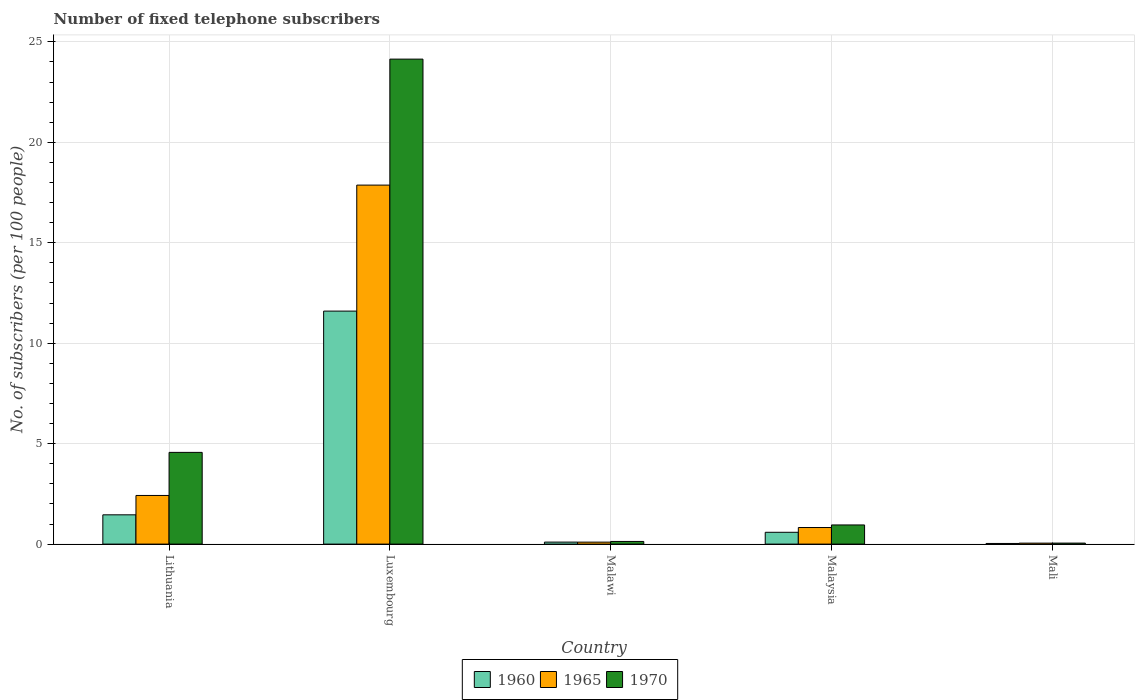How many groups of bars are there?
Ensure brevity in your answer.  5. Are the number of bars per tick equal to the number of legend labels?
Provide a succinct answer. Yes. Are the number of bars on each tick of the X-axis equal?
Offer a very short reply. Yes. How many bars are there on the 4th tick from the left?
Your response must be concise. 3. What is the label of the 1st group of bars from the left?
Your answer should be very brief. Lithuania. In how many cases, is the number of bars for a given country not equal to the number of legend labels?
Your answer should be compact. 0. What is the number of fixed telephone subscribers in 1960 in Lithuania?
Give a very brief answer. 1.46. Across all countries, what is the maximum number of fixed telephone subscribers in 1960?
Your answer should be very brief. 11.6. Across all countries, what is the minimum number of fixed telephone subscribers in 1970?
Offer a terse response. 0.05. In which country was the number of fixed telephone subscribers in 1970 maximum?
Your response must be concise. Luxembourg. In which country was the number of fixed telephone subscribers in 1965 minimum?
Your response must be concise. Mali. What is the total number of fixed telephone subscribers in 1965 in the graph?
Ensure brevity in your answer.  21.26. What is the difference between the number of fixed telephone subscribers in 1970 in Malaysia and that in Mali?
Make the answer very short. 0.9. What is the difference between the number of fixed telephone subscribers in 1960 in Lithuania and the number of fixed telephone subscribers in 1965 in Luxembourg?
Your answer should be compact. -16.41. What is the average number of fixed telephone subscribers in 1965 per country?
Provide a succinct answer. 4.25. What is the difference between the number of fixed telephone subscribers of/in 1970 and number of fixed telephone subscribers of/in 1960 in Lithuania?
Offer a very short reply. 3.11. In how many countries, is the number of fixed telephone subscribers in 1970 greater than 9?
Your answer should be very brief. 1. What is the ratio of the number of fixed telephone subscribers in 1960 in Malaysia to that in Mali?
Provide a succinct answer. 18.21. Is the number of fixed telephone subscribers in 1960 in Lithuania less than that in Malawi?
Offer a very short reply. No. What is the difference between the highest and the second highest number of fixed telephone subscribers in 1970?
Give a very brief answer. 23.19. What is the difference between the highest and the lowest number of fixed telephone subscribers in 1965?
Offer a very short reply. 17.82. What does the 1st bar from the left in Luxembourg represents?
Provide a succinct answer. 1960. What does the 2nd bar from the right in Lithuania represents?
Make the answer very short. 1965. How many bars are there?
Your response must be concise. 15. How many countries are there in the graph?
Your response must be concise. 5. Are the values on the major ticks of Y-axis written in scientific E-notation?
Offer a terse response. No. How are the legend labels stacked?
Give a very brief answer. Horizontal. What is the title of the graph?
Keep it short and to the point. Number of fixed telephone subscribers. What is the label or title of the X-axis?
Ensure brevity in your answer.  Country. What is the label or title of the Y-axis?
Offer a terse response. No. of subscribers (per 100 people). What is the No. of subscribers (per 100 people) of 1960 in Lithuania?
Make the answer very short. 1.46. What is the No. of subscribers (per 100 people) of 1965 in Lithuania?
Give a very brief answer. 2.42. What is the No. of subscribers (per 100 people) of 1970 in Lithuania?
Ensure brevity in your answer.  4.57. What is the No. of subscribers (per 100 people) in 1960 in Luxembourg?
Your answer should be compact. 11.6. What is the No. of subscribers (per 100 people) of 1965 in Luxembourg?
Keep it short and to the point. 17.87. What is the No. of subscribers (per 100 people) of 1970 in Luxembourg?
Provide a short and direct response. 24.14. What is the No. of subscribers (per 100 people) of 1960 in Malawi?
Ensure brevity in your answer.  0.1. What is the No. of subscribers (per 100 people) of 1965 in Malawi?
Provide a short and direct response. 0.1. What is the No. of subscribers (per 100 people) in 1970 in Malawi?
Give a very brief answer. 0.13. What is the No. of subscribers (per 100 people) of 1960 in Malaysia?
Your answer should be very brief. 0.59. What is the No. of subscribers (per 100 people) in 1965 in Malaysia?
Keep it short and to the point. 0.83. What is the No. of subscribers (per 100 people) of 1970 in Malaysia?
Provide a succinct answer. 0.95. What is the No. of subscribers (per 100 people) in 1960 in Mali?
Provide a succinct answer. 0.03. What is the No. of subscribers (per 100 people) of 1965 in Mali?
Give a very brief answer. 0.05. What is the No. of subscribers (per 100 people) of 1970 in Mali?
Make the answer very short. 0.05. Across all countries, what is the maximum No. of subscribers (per 100 people) in 1960?
Your answer should be compact. 11.6. Across all countries, what is the maximum No. of subscribers (per 100 people) in 1965?
Give a very brief answer. 17.87. Across all countries, what is the maximum No. of subscribers (per 100 people) of 1970?
Provide a succinct answer. 24.14. Across all countries, what is the minimum No. of subscribers (per 100 people) of 1960?
Provide a short and direct response. 0.03. Across all countries, what is the minimum No. of subscribers (per 100 people) of 1965?
Provide a succinct answer. 0.05. Across all countries, what is the minimum No. of subscribers (per 100 people) of 1970?
Your answer should be very brief. 0.05. What is the total No. of subscribers (per 100 people) of 1960 in the graph?
Give a very brief answer. 13.78. What is the total No. of subscribers (per 100 people) of 1965 in the graph?
Provide a short and direct response. 21.26. What is the total No. of subscribers (per 100 people) in 1970 in the graph?
Offer a very short reply. 29.84. What is the difference between the No. of subscribers (per 100 people) in 1960 in Lithuania and that in Luxembourg?
Give a very brief answer. -10.14. What is the difference between the No. of subscribers (per 100 people) in 1965 in Lithuania and that in Luxembourg?
Make the answer very short. -15.45. What is the difference between the No. of subscribers (per 100 people) of 1970 in Lithuania and that in Luxembourg?
Provide a short and direct response. -19.58. What is the difference between the No. of subscribers (per 100 people) in 1960 in Lithuania and that in Malawi?
Your answer should be very brief. 1.36. What is the difference between the No. of subscribers (per 100 people) in 1965 in Lithuania and that in Malawi?
Ensure brevity in your answer.  2.32. What is the difference between the No. of subscribers (per 100 people) in 1970 in Lithuania and that in Malawi?
Offer a very short reply. 4.43. What is the difference between the No. of subscribers (per 100 people) in 1960 in Lithuania and that in Malaysia?
Make the answer very short. 0.87. What is the difference between the No. of subscribers (per 100 people) in 1965 in Lithuania and that in Malaysia?
Provide a succinct answer. 1.6. What is the difference between the No. of subscribers (per 100 people) of 1970 in Lithuania and that in Malaysia?
Give a very brief answer. 3.61. What is the difference between the No. of subscribers (per 100 people) of 1960 in Lithuania and that in Mali?
Offer a terse response. 1.43. What is the difference between the No. of subscribers (per 100 people) of 1965 in Lithuania and that in Mali?
Your answer should be compact. 2.37. What is the difference between the No. of subscribers (per 100 people) of 1970 in Lithuania and that in Mali?
Provide a succinct answer. 4.52. What is the difference between the No. of subscribers (per 100 people) of 1960 in Luxembourg and that in Malawi?
Offer a very short reply. 11.5. What is the difference between the No. of subscribers (per 100 people) in 1965 in Luxembourg and that in Malawi?
Ensure brevity in your answer.  17.77. What is the difference between the No. of subscribers (per 100 people) in 1970 in Luxembourg and that in Malawi?
Your answer should be compact. 24.01. What is the difference between the No. of subscribers (per 100 people) of 1960 in Luxembourg and that in Malaysia?
Give a very brief answer. 11.01. What is the difference between the No. of subscribers (per 100 people) in 1965 in Luxembourg and that in Malaysia?
Provide a short and direct response. 17.04. What is the difference between the No. of subscribers (per 100 people) of 1970 in Luxembourg and that in Malaysia?
Your answer should be very brief. 23.19. What is the difference between the No. of subscribers (per 100 people) in 1960 in Luxembourg and that in Mali?
Ensure brevity in your answer.  11.57. What is the difference between the No. of subscribers (per 100 people) in 1965 in Luxembourg and that in Mali?
Your answer should be compact. 17.82. What is the difference between the No. of subscribers (per 100 people) of 1970 in Luxembourg and that in Mali?
Make the answer very short. 24.09. What is the difference between the No. of subscribers (per 100 people) in 1960 in Malawi and that in Malaysia?
Keep it short and to the point. -0.49. What is the difference between the No. of subscribers (per 100 people) of 1965 in Malawi and that in Malaysia?
Offer a very short reply. -0.73. What is the difference between the No. of subscribers (per 100 people) in 1970 in Malawi and that in Malaysia?
Ensure brevity in your answer.  -0.82. What is the difference between the No. of subscribers (per 100 people) in 1960 in Malawi and that in Mali?
Provide a short and direct response. 0.07. What is the difference between the No. of subscribers (per 100 people) in 1965 in Malawi and that in Mali?
Make the answer very short. 0.05. What is the difference between the No. of subscribers (per 100 people) in 1970 in Malawi and that in Mali?
Provide a short and direct response. 0.08. What is the difference between the No. of subscribers (per 100 people) in 1960 in Malaysia and that in Mali?
Ensure brevity in your answer.  0.56. What is the difference between the No. of subscribers (per 100 people) in 1965 in Malaysia and that in Mali?
Your response must be concise. 0.78. What is the difference between the No. of subscribers (per 100 people) in 1970 in Malaysia and that in Mali?
Your answer should be very brief. 0.9. What is the difference between the No. of subscribers (per 100 people) of 1960 in Lithuania and the No. of subscribers (per 100 people) of 1965 in Luxembourg?
Make the answer very short. -16.41. What is the difference between the No. of subscribers (per 100 people) in 1960 in Lithuania and the No. of subscribers (per 100 people) in 1970 in Luxembourg?
Give a very brief answer. -22.68. What is the difference between the No. of subscribers (per 100 people) of 1965 in Lithuania and the No. of subscribers (per 100 people) of 1970 in Luxembourg?
Your answer should be compact. -21.72. What is the difference between the No. of subscribers (per 100 people) in 1960 in Lithuania and the No. of subscribers (per 100 people) in 1965 in Malawi?
Offer a very short reply. 1.36. What is the difference between the No. of subscribers (per 100 people) of 1960 in Lithuania and the No. of subscribers (per 100 people) of 1970 in Malawi?
Offer a very short reply. 1.33. What is the difference between the No. of subscribers (per 100 people) in 1965 in Lithuania and the No. of subscribers (per 100 people) in 1970 in Malawi?
Keep it short and to the point. 2.29. What is the difference between the No. of subscribers (per 100 people) in 1960 in Lithuania and the No. of subscribers (per 100 people) in 1965 in Malaysia?
Provide a short and direct response. 0.63. What is the difference between the No. of subscribers (per 100 people) of 1960 in Lithuania and the No. of subscribers (per 100 people) of 1970 in Malaysia?
Your answer should be very brief. 0.5. What is the difference between the No. of subscribers (per 100 people) in 1965 in Lithuania and the No. of subscribers (per 100 people) in 1970 in Malaysia?
Your answer should be compact. 1.47. What is the difference between the No. of subscribers (per 100 people) in 1960 in Lithuania and the No. of subscribers (per 100 people) in 1965 in Mali?
Make the answer very short. 1.41. What is the difference between the No. of subscribers (per 100 people) in 1960 in Lithuania and the No. of subscribers (per 100 people) in 1970 in Mali?
Ensure brevity in your answer.  1.41. What is the difference between the No. of subscribers (per 100 people) in 1965 in Lithuania and the No. of subscribers (per 100 people) in 1970 in Mali?
Your answer should be very brief. 2.37. What is the difference between the No. of subscribers (per 100 people) of 1960 in Luxembourg and the No. of subscribers (per 100 people) of 1965 in Malawi?
Provide a succinct answer. 11.5. What is the difference between the No. of subscribers (per 100 people) of 1960 in Luxembourg and the No. of subscribers (per 100 people) of 1970 in Malawi?
Give a very brief answer. 11.47. What is the difference between the No. of subscribers (per 100 people) in 1965 in Luxembourg and the No. of subscribers (per 100 people) in 1970 in Malawi?
Your response must be concise. 17.74. What is the difference between the No. of subscribers (per 100 people) of 1960 in Luxembourg and the No. of subscribers (per 100 people) of 1965 in Malaysia?
Offer a very short reply. 10.77. What is the difference between the No. of subscribers (per 100 people) in 1960 in Luxembourg and the No. of subscribers (per 100 people) in 1970 in Malaysia?
Keep it short and to the point. 10.64. What is the difference between the No. of subscribers (per 100 people) in 1965 in Luxembourg and the No. of subscribers (per 100 people) in 1970 in Malaysia?
Keep it short and to the point. 16.92. What is the difference between the No. of subscribers (per 100 people) of 1960 in Luxembourg and the No. of subscribers (per 100 people) of 1965 in Mali?
Provide a succinct answer. 11.55. What is the difference between the No. of subscribers (per 100 people) in 1960 in Luxembourg and the No. of subscribers (per 100 people) in 1970 in Mali?
Provide a succinct answer. 11.55. What is the difference between the No. of subscribers (per 100 people) in 1965 in Luxembourg and the No. of subscribers (per 100 people) in 1970 in Mali?
Your answer should be very brief. 17.82. What is the difference between the No. of subscribers (per 100 people) in 1960 in Malawi and the No. of subscribers (per 100 people) in 1965 in Malaysia?
Your answer should be compact. -0.73. What is the difference between the No. of subscribers (per 100 people) in 1960 in Malawi and the No. of subscribers (per 100 people) in 1970 in Malaysia?
Your answer should be compact. -0.85. What is the difference between the No. of subscribers (per 100 people) in 1965 in Malawi and the No. of subscribers (per 100 people) in 1970 in Malaysia?
Ensure brevity in your answer.  -0.86. What is the difference between the No. of subscribers (per 100 people) of 1960 in Malawi and the No. of subscribers (per 100 people) of 1965 in Mali?
Keep it short and to the point. 0.05. What is the difference between the No. of subscribers (per 100 people) of 1960 in Malawi and the No. of subscribers (per 100 people) of 1970 in Mali?
Offer a terse response. 0.05. What is the difference between the No. of subscribers (per 100 people) of 1965 in Malawi and the No. of subscribers (per 100 people) of 1970 in Mali?
Keep it short and to the point. 0.05. What is the difference between the No. of subscribers (per 100 people) in 1960 in Malaysia and the No. of subscribers (per 100 people) in 1965 in Mali?
Your response must be concise. 0.54. What is the difference between the No. of subscribers (per 100 people) in 1960 in Malaysia and the No. of subscribers (per 100 people) in 1970 in Mali?
Provide a succinct answer. 0.54. What is the difference between the No. of subscribers (per 100 people) of 1965 in Malaysia and the No. of subscribers (per 100 people) of 1970 in Mali?
Make the answer very short. 0.78. What is the average No. of subscribers (per 100 people) in 1960 per country?
Your response must be concise. 2.76. What is the average No. of subscribers (per 100 people) of 1965 per country?
Make the answer very short. 4.25. What is the average No. of subscribers (per 100 people) in 1970 per country?
Keep it short and to the point. 5.97. What is the difference between the No. of subscribers (per 100 people) in 1960 and No. of subscribers (per 100 people) in 1965 in Lithuania?
Offer a very short reply. -0.96. What is the difference between the No. of subscribers (per 100 people) in 1960 and No. of subscribers (per 100 people) in 1970 in Lithuania?
Provide a succinct answer. -3.11. What is the difference between the No. of subscribers (per 100 people) of 1965 and No. of subscribers (per 100 people) of 1970 in Lithuania?
Offer a terse response. -2.14. What is the difference between the No. of subscribers (per 100 people) in 1960 and No. of subscribers (per 100 people) in 1965 in Luxembourg?
Make the answer very short. -6.27. What is the difference between the No. of subscribers (per 100 people) in 1960 and No. of subscribers (per 100 people) in 1970 in Luxembourg?
Make the answer very short. -12.54. What is the difference between the No. of subscribers (per 100 people) of 1965 and No. of subscribers (per 100 people) of 1970 in Luxembourg?
Keep it short and to the point. -6.27. What is the difference between the No. of subscribers (per 100 people) of 1960 and No. of subscribers (per 100 people) of 1965 in Malawi?
Make the answer very short. 0. What is the difference between the No. of subscribers (per 100 people) of 1960 and No. of subscribers (per 100 people) of 1970 in Malawi?
Provide a short and direct response. -0.03. What is the difference between the No. of subscribers (per 100 people) in 1965 and No. of subscribers (per 100 people) in 1970 in Malawi?
Keep it short and to the point. -0.03. What is the difference between the No. of subscribers (per 100 people) in 1960 and No. of subscribers (per 100 people) in 1965 in Malaysia?
Your response must be concise. -0.24. What is the difference between the No. of subscribers (per 100 people) in 1960 and No. of subscribers (per 100 people) in 1970 in Malaysia?
Ensure brevity in your answer.  -0.36. What is the difference between the No. of subscribers (per 100 people) in 1965 and No. of subscribers (per 100 people) in 1970 in Malaysia?
Offer a very short reply. -0.13. What is the difference between the No. of subscribers (per 100 people) in 1960 and No. of subscribers (per 100 people) in 1965 in Mali?
Make the answer very short. -0.02. What is the difference between the No. of subscribers (per 100 people) in 1960 and No. of subscribers (per 100 people) in 1970 in Mali?
Provide a succinct answer. -0.02. What is the difference between the No. of subscribers (per 100 people) of 1965 and No. of subscribers (per 100 people) of 1970 in Mali?
Your answer should be compact. -0. What is the ratio of the No. of subscribers (per 100 people) in 1960 in Lithuania to that in Luxembourg?
Give a very brief answer. 0.13. What is the ratio of the No. of subscribers (per 100 people) of 1965 in Lithuania to that in Luxembourg?
Your response must be concise. 0.14. What is the ratio of the No. of subscribers (per 100 people) in 1970 in Lithuania to that in Luxembourg?
Provide a succinct answer. 0.19. What is the ratio of the No. of subscribers (per 100 people) of 1960 in Lithuania to that in Malawi?
Provide a short and direct response. 14.68. What is the ratio of the No. of subscribers (per 100 people) in 1965 in Lithuania to that in Malawi?
Your answer should be compact. 24.67. What is the ratio of the No. of subscribers (per 100 people) of 1970 in Lithuania to that in Malawi?
Keep it short and to the point. 34.46. What is the ratio of the No. of subscribers (per 100 people) in 1960 in Lithuania to that in Malaysia?
Your answer should be compact. 2.48. What is the ratio of the No. of subscribers (per 100 people) in 1965 in Lithuania to that in Malaysia?
Keep it short and to the point. 2.93. What is the ratio of the No. of subscribers (per 100 people) of 1970 in Lithuania to that in Malaysia?
Your answer should be very brief. 4.79. What is the ratio of the No. of subscribers (per 100 people) in 1960 in Lithuania to that in Mali?
Your answer should be compact. 45.1. What is the ratio of the No. of subscribers (per 100 people) in 1965 in Lithuania to that in Mali?
Ensure brevity in your answer.  50.05. What is the ratio of the No. of subscribers (per 100 people) of 1970 in Lithuania to that in Mali?
Your response must be concise. 91.44. What is the ratio of the No. of subscribers (per 100 people) in 1960 in Luxembourg to that in Malawi?
Your response must be concise. 116.81. What is the ratio of the No. of subscribers (per 100 people) of 1965 in Luxembourg to that in Malawi?
Your answer should be very brief. 182.09. What is the ratio of the No. of subscribers (per 100 people) in 1970 in Luxembourg to that in Malawi?
Ensure brevity in your answer.  182.25. What is the ratio of the No. of subscribers (per 100 people) of 1960 in Luxembourg to that in Malaysia?
Your answer should be compact. 19.71. What is the ratio of the No. of subscribers (per 100 people) of 1965 in Luxembourg to that in Malaysia?
Your response must be concise. 21.65. What is the ratio of the No. of subscribers (per 100 people) in 1970 in Luxembourg to that in Malaysia?
Your answer should be very brief. 25.32. What is the ratio of the No. of subscribers (per 100 people) in 1960 in Luxembourg to that in Mali?
Provide a succinct answer. 358.85. What is the ratio of the No. of subscribers (per 100 people) of 1965 in Luxembourg to that in Mali?
Ensure brevity in your answer.  369.38. What is the ratio of the No. of subscribers (per 100 people) in 1970 in Luxembourg to that in Mali?
Keep it short and to the point. 483.51. What is the ratio of the No. of subscribers (per 100 people) of 1960 in Malawi to that in Malaysia?
Ensure brevity in your answer.  0.17. What is the ratio of the No. of subscribers (per 100 people) in 1965 in Malawi to that in Malaysia?
Offer a terse response. 0.12. What is the ratio of the No. of subscribers (per 100 people) in 1970 in Malawi to that in Malaysia?
Offer a very short reply. 0.14. What is the ratio of the No. of subscribers (per 100 people) in 1960 in Malawi to that in Mali?
Your response must be concise. 3.07. What is the ratio of the No. of subscribers (per 100 people) in 1965 in Malawi to that in Mali?
Offer a terse response. 2.03. What is the ratio of the No. of subscribers (per 100 people) in 1970 in Malawi to that in Mali?
Your answer should be very brief. 2.65. What is the ratio of the No. of subscribers (per 100 people) of 1960 in Malaysia to that in Mali?
Give a very brief answer. 18.21. What is the ratio of the No. of subscribers (per 100 people) in 1965 in Malaysia to that in Mali?
Provide a succinct answer. 17.06. What is the ratio of the No. of subscribers (per 100 people) of 1970 in Malaysia to that in Mali?
Provide a short and direct response. 19.1. What is the difference between the highest and the second highest No. of subscribers (per 100 people) of 1960?
Ensure brevity in your answer.  10.14. What is the difference between the highest and the second highest No. of subscribers (per 100 people) of 1965?
Provide a succinct answer. 15.45. What is the difference between the highest and the second highest No. of subscribers (per 100 people) of 1970?
Your answer should be very brief. 19.58. What is the difference between the highest and the lowest No. of subscribers (per 100 people) in 1960?
Offer a very short reply. 11.57. What is the difference between the highest and the lowest No. of subscribers (per 100 people) of 1965?
Ensure brevity in your answer.  17.82. What is the difference between the highest and the lowest No. of subscribers (per 100 people) of 1970?
Provide a succinct answer. 24.09. 